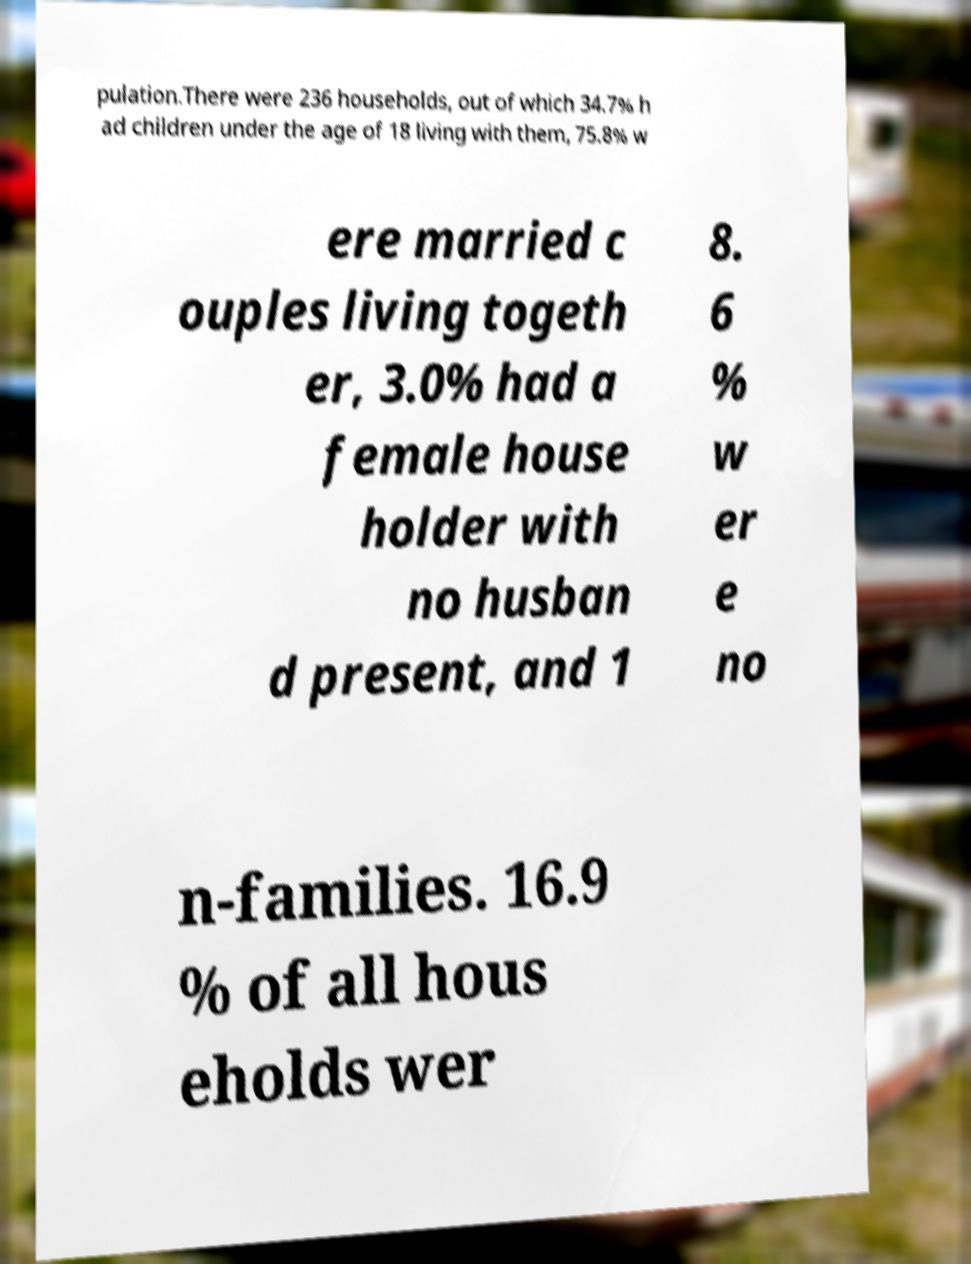Can you accurately transcribe the text from the provided image for me? pulation.There were 236 households, out of which 34.7% h ad children under the age of 18 living with them, 75.8% w ere married c ouples living togeth er, 3.0% had a female house holder with no husban d present, and 1 8. 6 % w er e no n-families. 16.9 % of all hous eholds wer 